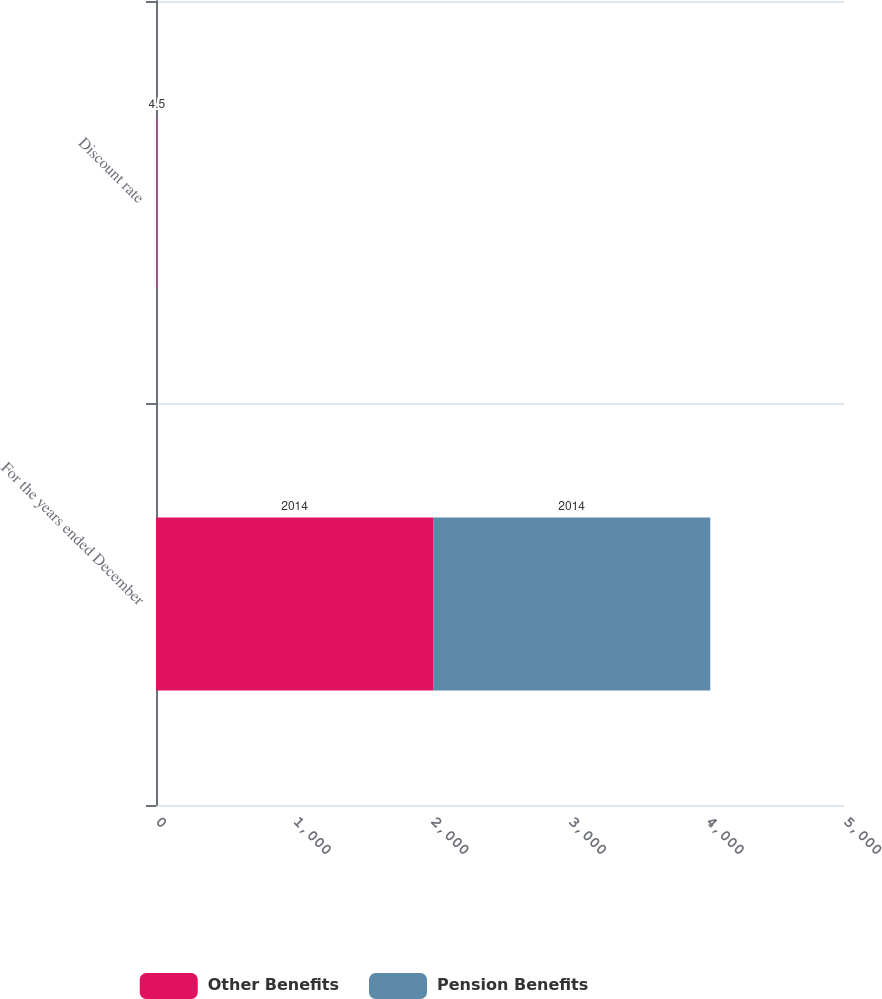<chart> <loc_0><loc_0><loc_500><loc_500><stacked_bar_chart><ecel><fcel>For the years ended December<fcel>Discount rate<nl><fcel>Other Benefits<fcel>2014<fcel>4.5<nl><fcel>Pension Benefits<fcel>2014<fcel>4.5<nl></chart> 